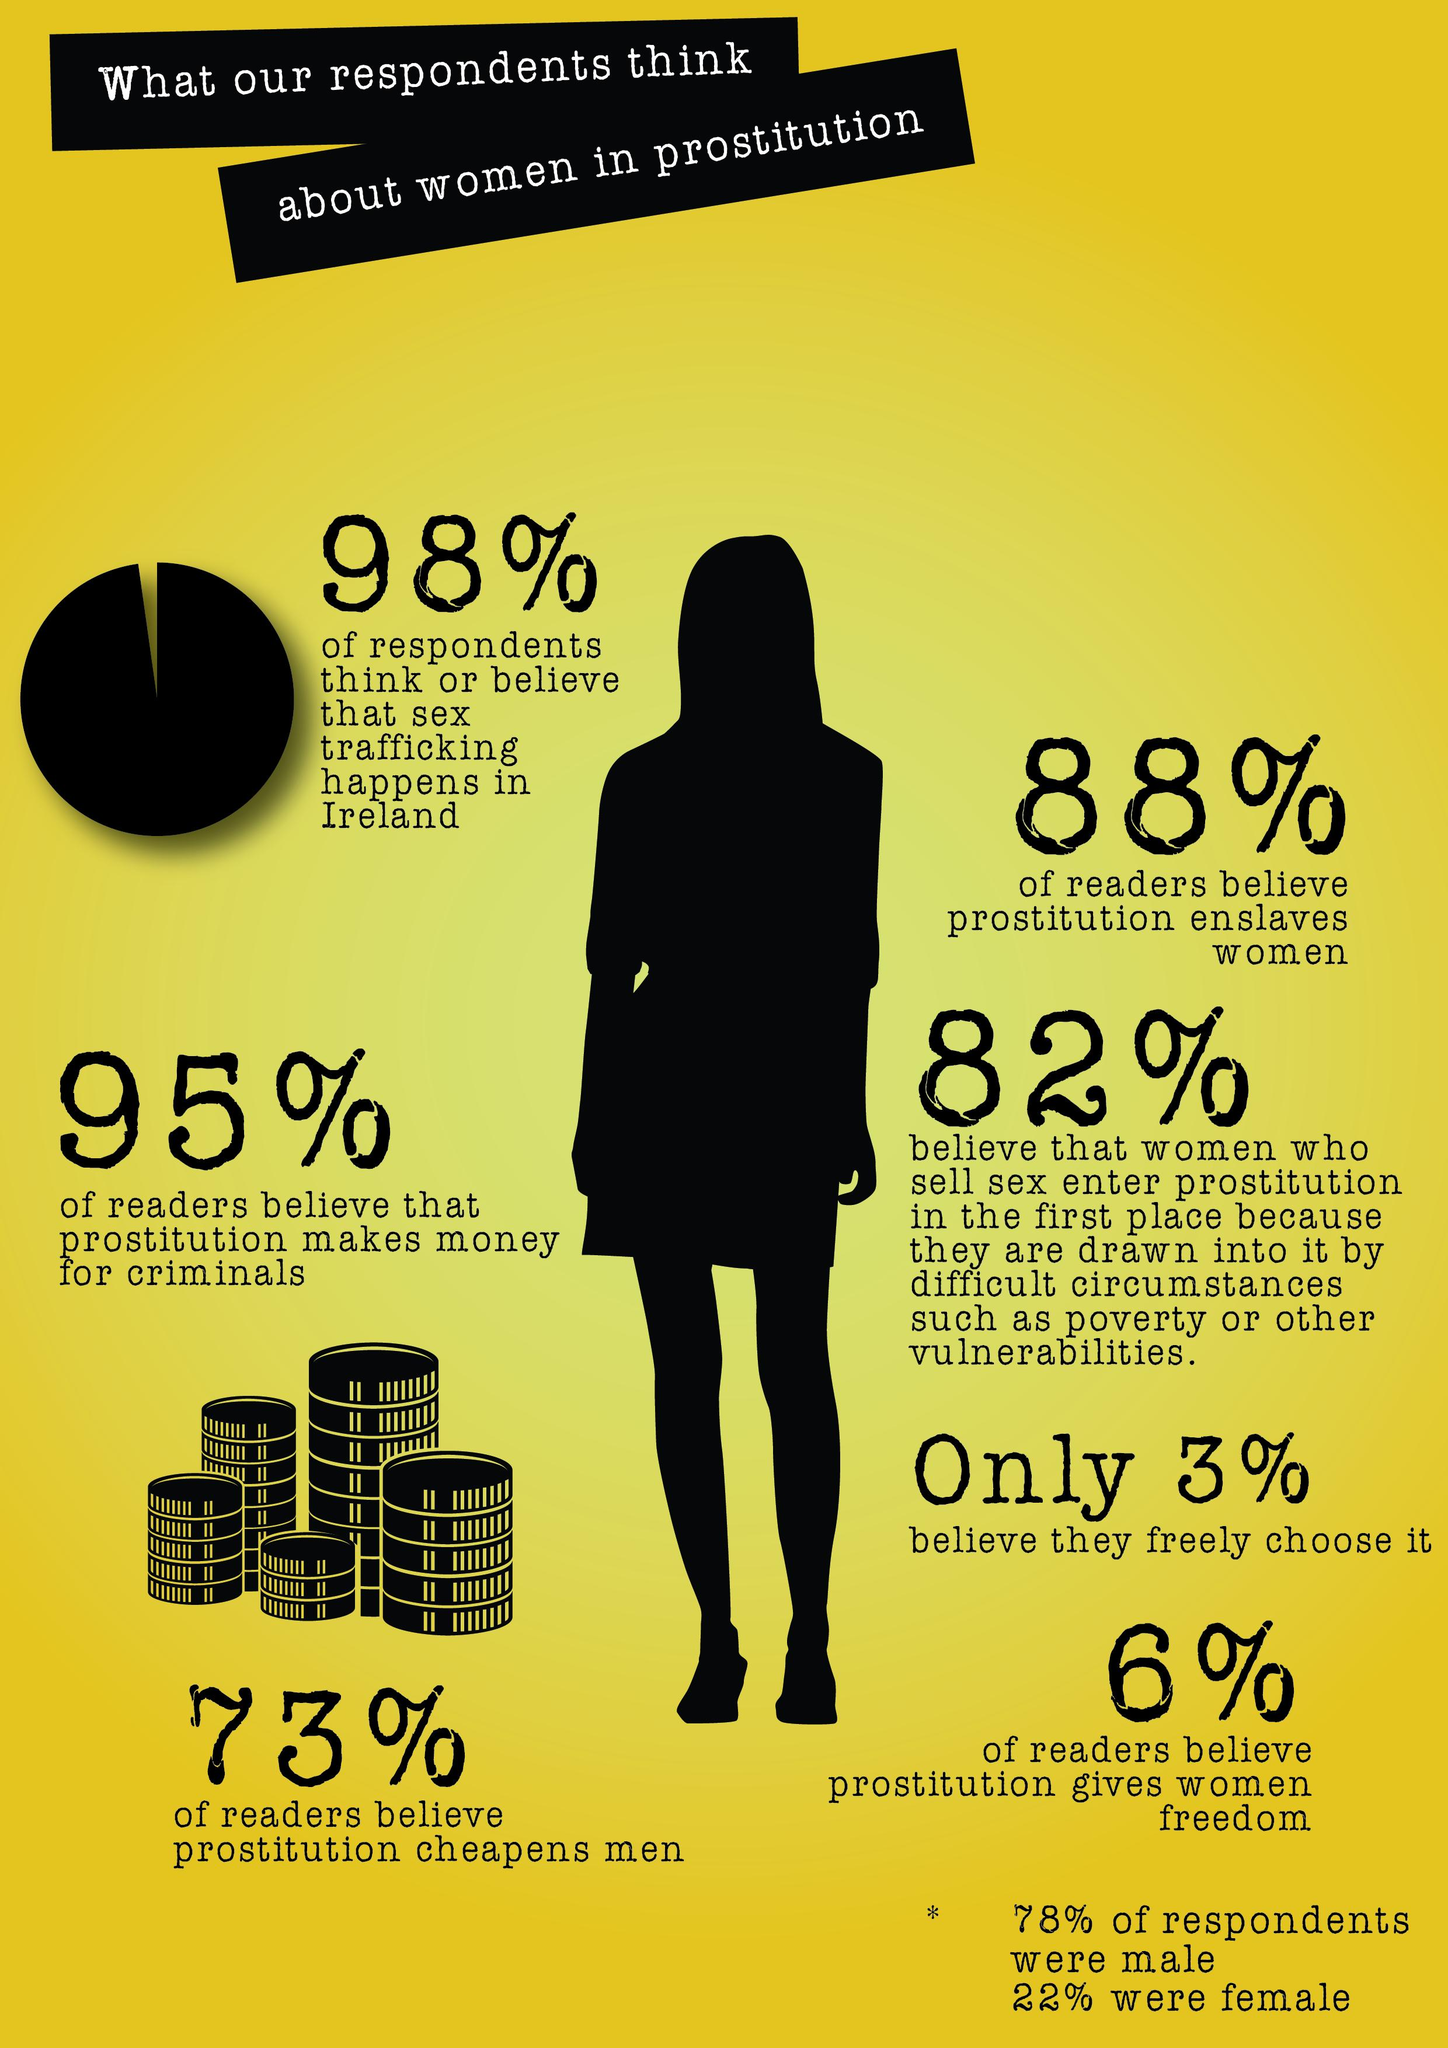Draw attention to some important aspects in this diagram. According to a recent study, 94% of readers do not believe that prostitution gives women freedom. According to a recent survey, only 5% of readers believe that prostitution generates profits for criminals. According to a survey, 27% of readers do not believe that prostitution cheapens men. According to the survey, only 2% of respondents do not believe that sex trafficking happens in Ireland. A study found that 12% of readers do not believe that prostitution enslaves women. 